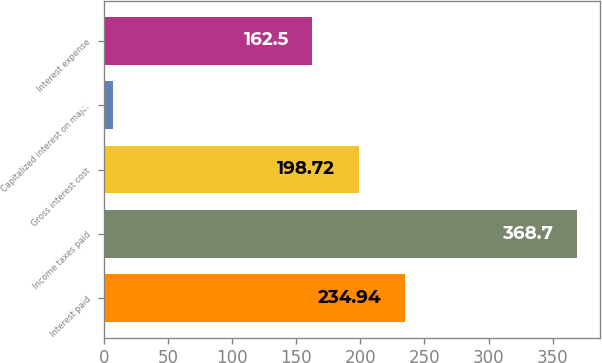Convert chart. <chart><loc_0><loc_0><loc_500><loc_500><bar_chart><fcel>Interest paid<fcel>Income taxes paid<fcel>Gross interest cost<fcel>Capitalized interest on major<fcel>Interest expense<nl><fcel>234.94<fcel>368.7<fcel>198.72<fcel>6.5<fcel>162.5<nl></chart> 